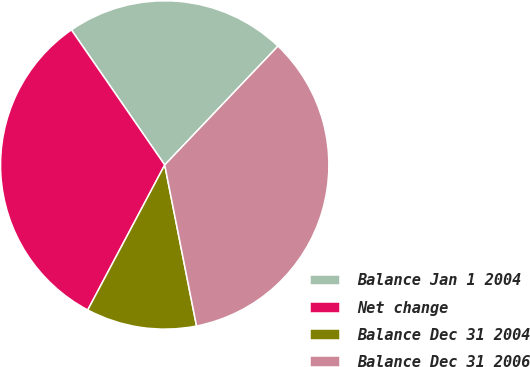Convert chart. <chart><loc_0><loc_0><loc_500><loc_500><pie_chart><fcel>Balance Jan 1 2004<fcel>Net change<fcel>Balance Dec 31 2004<fcel>Balance Dec 31 2006<nl><fcel>21.74%<fcel>32.61%<fcel>10.87%<fcel>34.78%<nl></chart> 